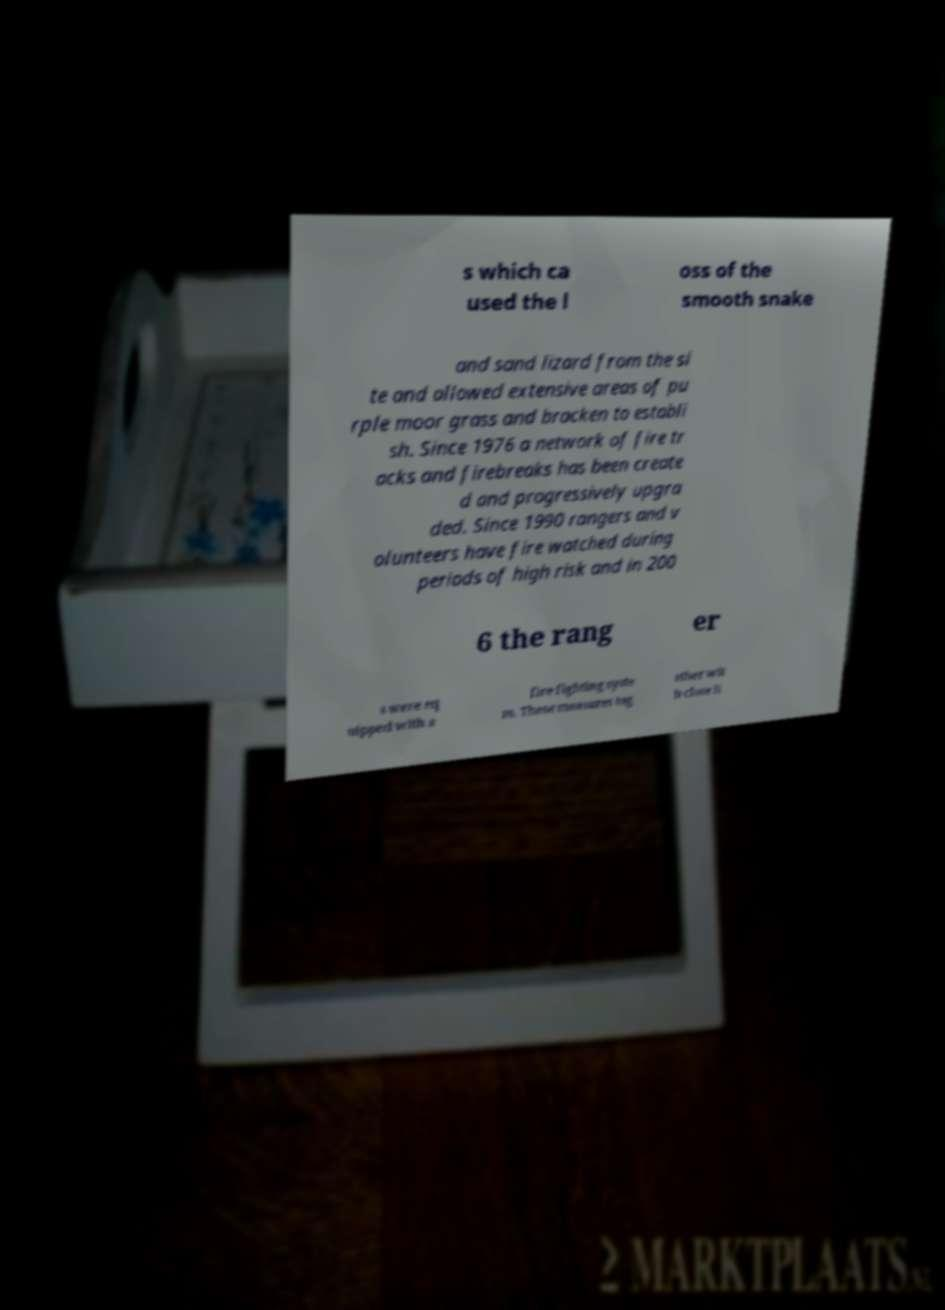Could you extract and type out the text from this image? s which ca used the l oss of the smooth snake and sand lizard from the si te and allowed extensive areas of pu rple moor grass and bracken to establi sh. Since 1976 a network of fire tr acks and firebreaks has been create d and progressively upgra ded. Since 1990 rangers and v olunteers have fire watched during periods of high risk and in 200 6 the rang er s were eq uipped with a fire fighting syste m. These measures tog ether wit h close li 